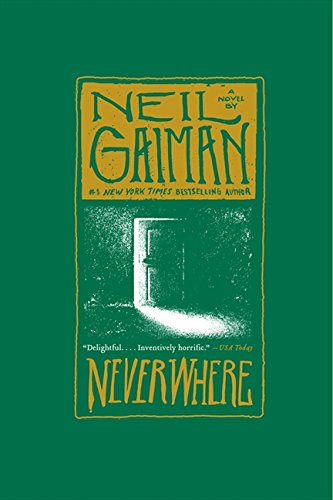Is this book related to Education & Teaching? No, 'Neverwhere: A Novel' does not fall under the Education & Teaching category. It primarily revolves around fantasy and imaginative storytelling. 